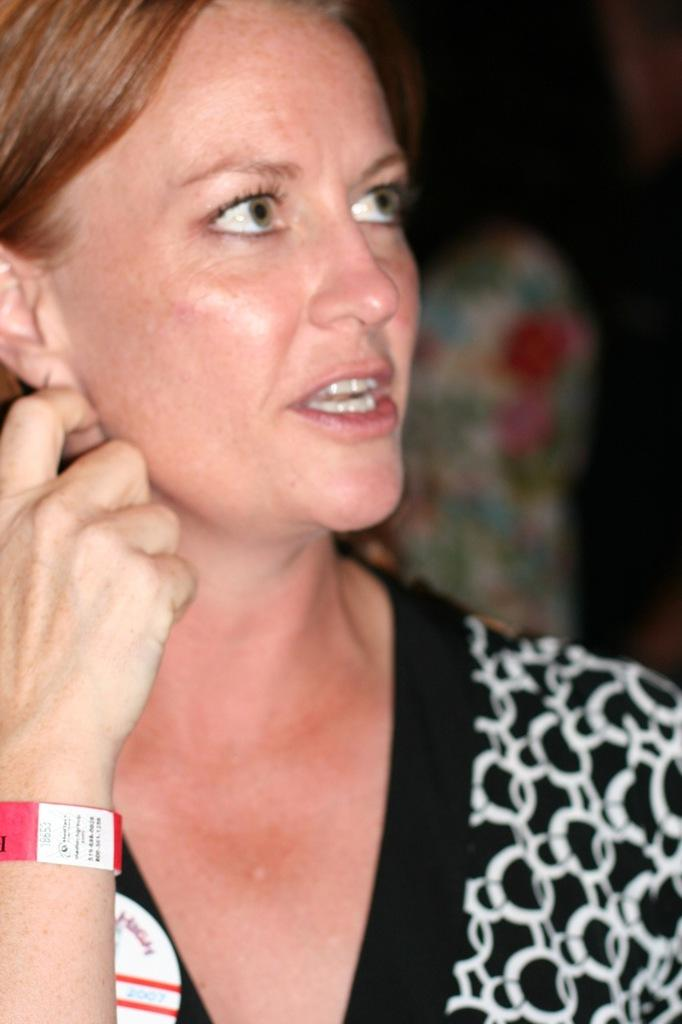What can be seen in the image? There is a person in the image. Can you describe the person's clothing? The person is wearing a black and white top. What is the color of the person's hair? The person has brown hair. How would you describe the background of the image? The background of the image is blurred. What type of wire can be seen in the person's hair in the image? There is no wire present in the person's hair in the image. What kind of field is visible in the background of the image? There is no field visible in the background of the image; the background is blurred. 